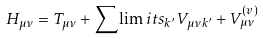<formula> <loc_0><loc_0><loc_500><loc_500>H _ { \mu \nu } = T _ { \mu \nu } + \sum \lim i t s _ { k ^ { \prime } } V _ { \mu \nu k ^ { \prime } } + V _ { \mu \nu } ^ { ( v ) }</formula> 